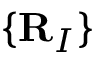<formula> <loc_0><loc_0><loc_500><loc_500>\{ R _ { I } \}</formula> 